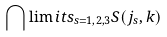<formula> <loc_0><loc_0><loc_500><loc_500>{ \bigcap \lim i t s _ { s = 1 , 2 , 3 } } S ( j _ { s } , k )</formula> 